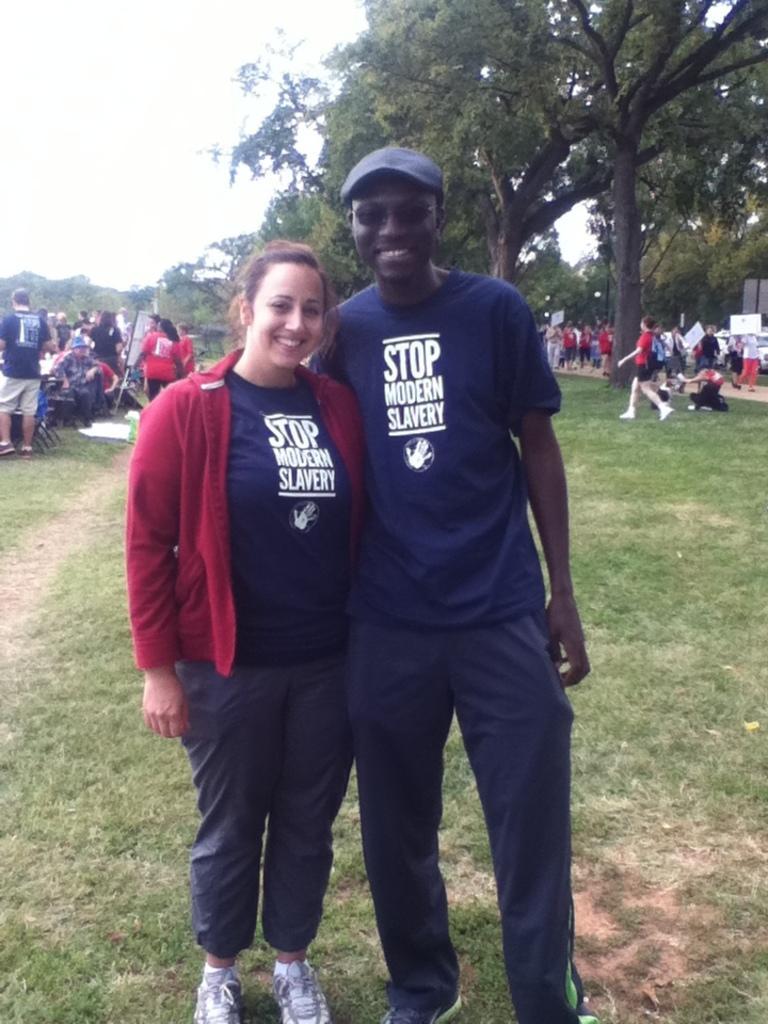In one or two sentences, can you explain what this image depicts? In this picture I can see there are two people standing and smiling and they are wearing same t-shirt and in the backdrop on to right there are few people running and there are some people on to left who are standing and there are trees and the sky is clear. 